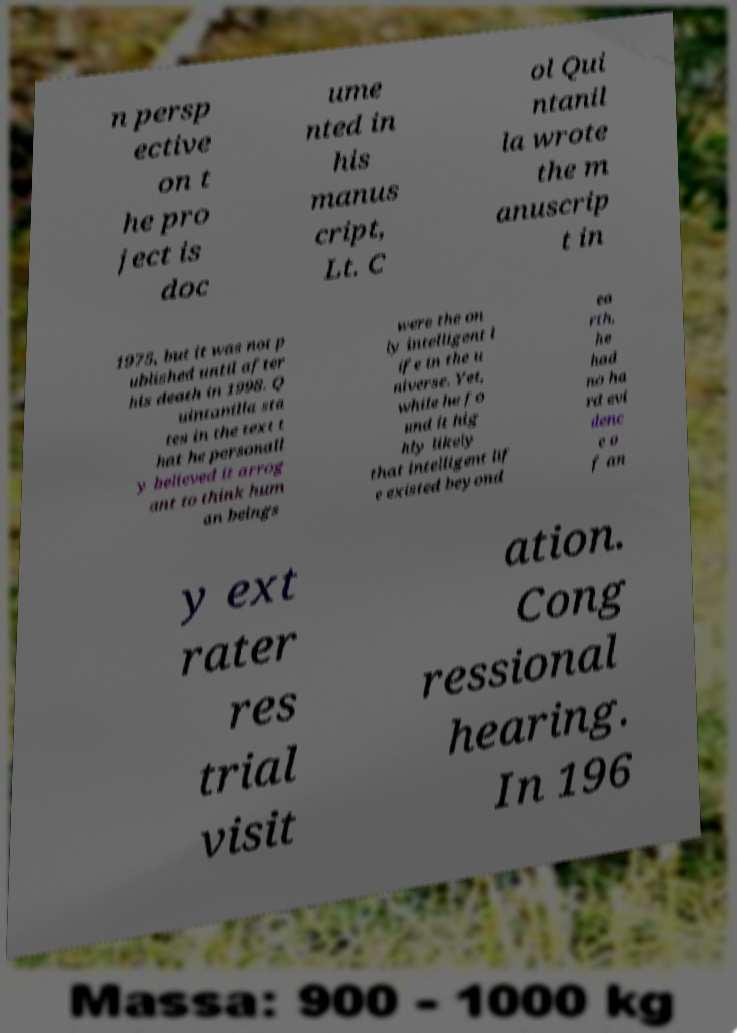Can you read and provide the text displayed in the image?This photo seems to have some interesting text. Can you extract and type it out for me? n persp ective on t he pro ject is doc ume nted in his manus cript, Lt. C ol Qui ntanil la wrote the m anuscrip t in 1975, but it was not p ublished until after his death in 1998. Q uintanilla sta tes in the text t hat he personall y believed it arrog ant to think hum an beings were the on ly intelligent l ife in the u niverse. Yet, while he fo und it hig hly likely that intelligent lif e existed beyond ea rth, he had no ha rd evi denc e o f an y ext rater res trial visit ation. Cong ressional hearing. In 196 